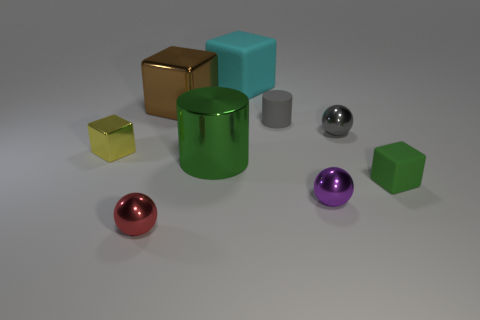Subtract all red shiny spheres. How many spheres are left? 2 Add 1 cubes. How many objects exist? 10 Subtract all cyan blocks. How many blocks are left? 3 Subtract 2 spheres. How many spheres are left? 1 Subtract all cubes. How many objects are left? 5 Subtract all green blocks. How many green spheres are left? 0 Subtract all red rubber objects. Subtract all blocks. How many objects are left? 5 Add 5 matte cubes. How many matte cubes are left? 7 Add 1 large green metal things. How many large green metal things exist? 2 Subtract 1 gray cylinders. How many objects are left? 8 